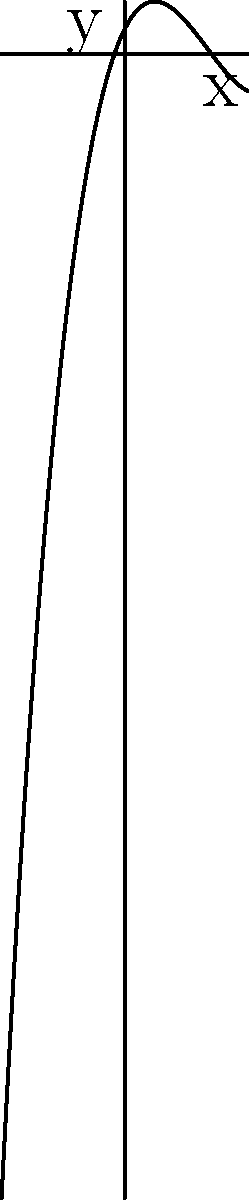As a self-published writer exploring mathematical concepts for a potential novel, you come across the graph of a polynomial function. The function appears to be of odd degree. Based on the end behavior shown in the graph, what can you conclude about the leading coefficient of this polynomial? Let's approach this step-by-step:

1) First, recall that for a polynomial of odd degree $n$, the end behavior is determined by the term with the highest degree (the leading term).

2) The general form of such a polynomial is $f(x) = ax^n + \text{lower degree terms}$, where $a$ is the leading coefficient and $n$ is odd.

3) For odd degree polynomials:
   - If $a > 0$, as $x \to +\infty$, $f(x) \to +\infty$, and as $x \to -\infty$, $f(x) \to -\infty$
   - If $a < 0$, as $x \to +\infty$, $f(x) \to -\infty$, and as $x \to -\infty$, $f(x) \to +\infty$

4) Looking at the graph:
   - As $x$ increases towards positive infinity, $y$ also increases towards positive infinity.
   - As $x$ decreases towards negative infinity, $y$ decreases towards negative infinity.

5) This behavior matches the case where the leading coefficient $a$ is positive.

Therefore, we can conclude that the leading coefficient of this polynomial is positive.
Answer: The leading coefficient is positive. 